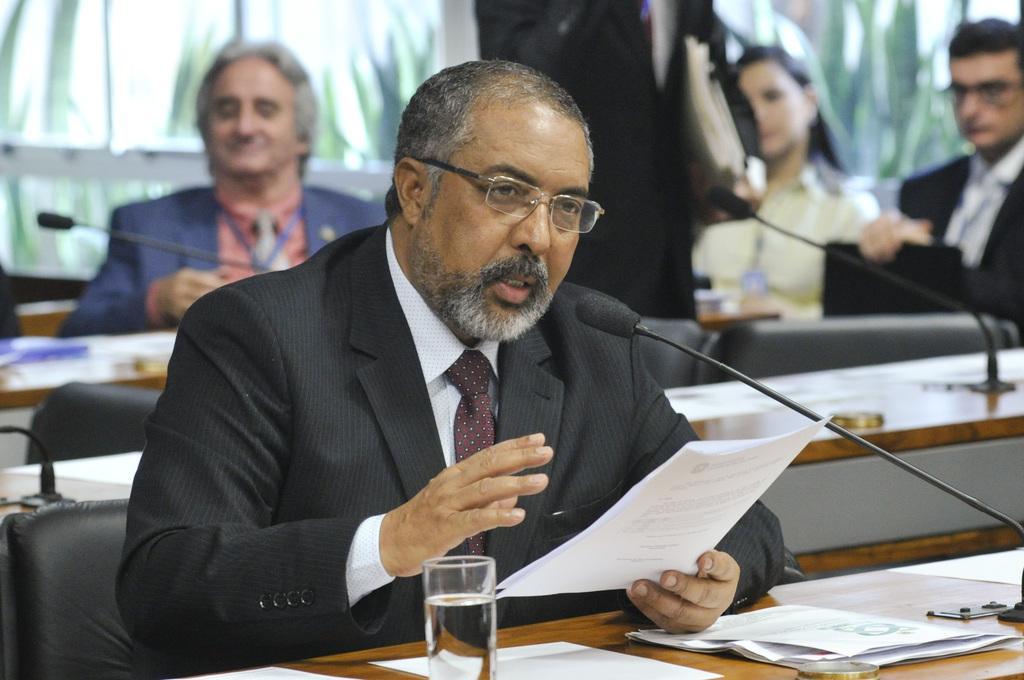Describe this image in one or two sentences. Here in the middle we can see a man sitting on chair with table in front of him having microphone to it and he is having papers in his hands speaking something and there is a glass of water on the table and there are some papers presented on the table and behind him we can see group of people sitting 